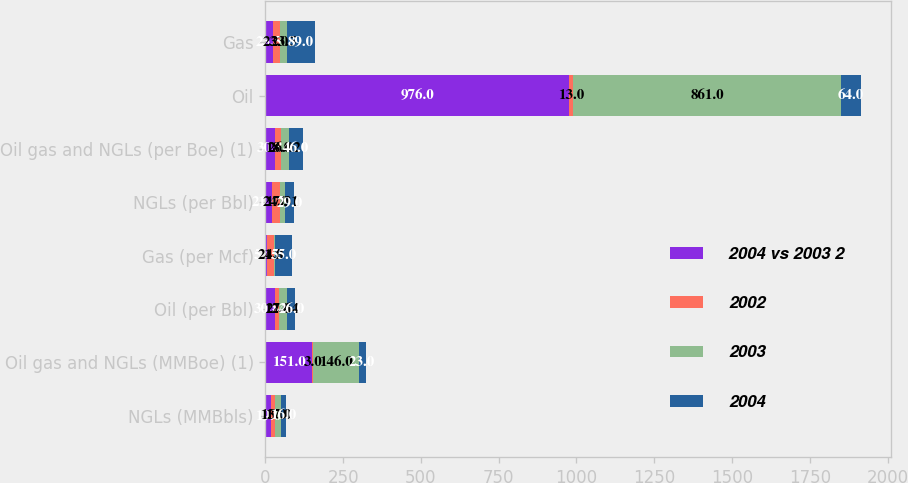Convert chart. <chart><loc_0><loc_0><loc_500><loc_500><stacked_bar_chart><ecel><fcel>NGLs (MMBbls)<fcel>Oil gas and NGLs (MMBoe) (1)<fcel>Oil (per Bbl)<fcel>Gas (per Mcf)<fcel>NGLs (per Bbl)<fcel>Oil gas and NGLs (per Boe) (1)<fcel>Oil<fcel>Gas<nl><fcel>2004 vs 2003 2<fcel>19<fcel>151<fcel>30.84<fcel>5.43<fcel>21.47<fcel>30.8<fcel>976<fcel>23.5<nl><fcel>2002<fcel>13<fcel>3<fcel>12<fcel>21<fcel>24<fcel>18<fcel>13<fcel>23<nl><fcel>2003<fcel>17<fcel>146<fcel>27.64<fcel>4.5<fcel>17.31<fcel>26.02<fcel>861<fcel>23.5<nl><fcel>2004<fcel>16<fcel>23<fcel>26<fcel>55<fcel>29<fcel>46<fcel>64<fcel>89<nl></chart> 